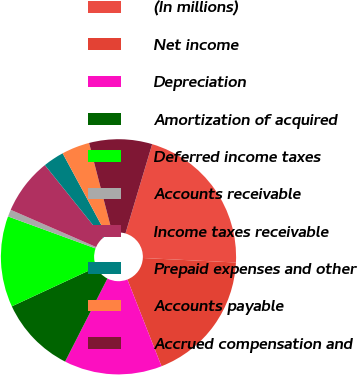<chart> <loc_0><loc_0><loc_500><loc_500><pie_chart><fcel>(In millions)<fcel>Net income<fcel>Depreciation<fcel>Amortization of acquired<fcel>Deferred income taxes<fcel>Accounts receivable<fcel>Income taxes receivable<fcel>Prepaid expenses and other<fcel>Accounts payable<fcel>Accrued compensation and<nl><fcel>21.15%<fcel>18.27%<fcel>13.46%<fcel>10.58%<fcel>12.5%<fcel>0.97%<fcel>7.69%<fcel>2.89%<fcel>3.85%<fcel>8.65%<nl></chart> 